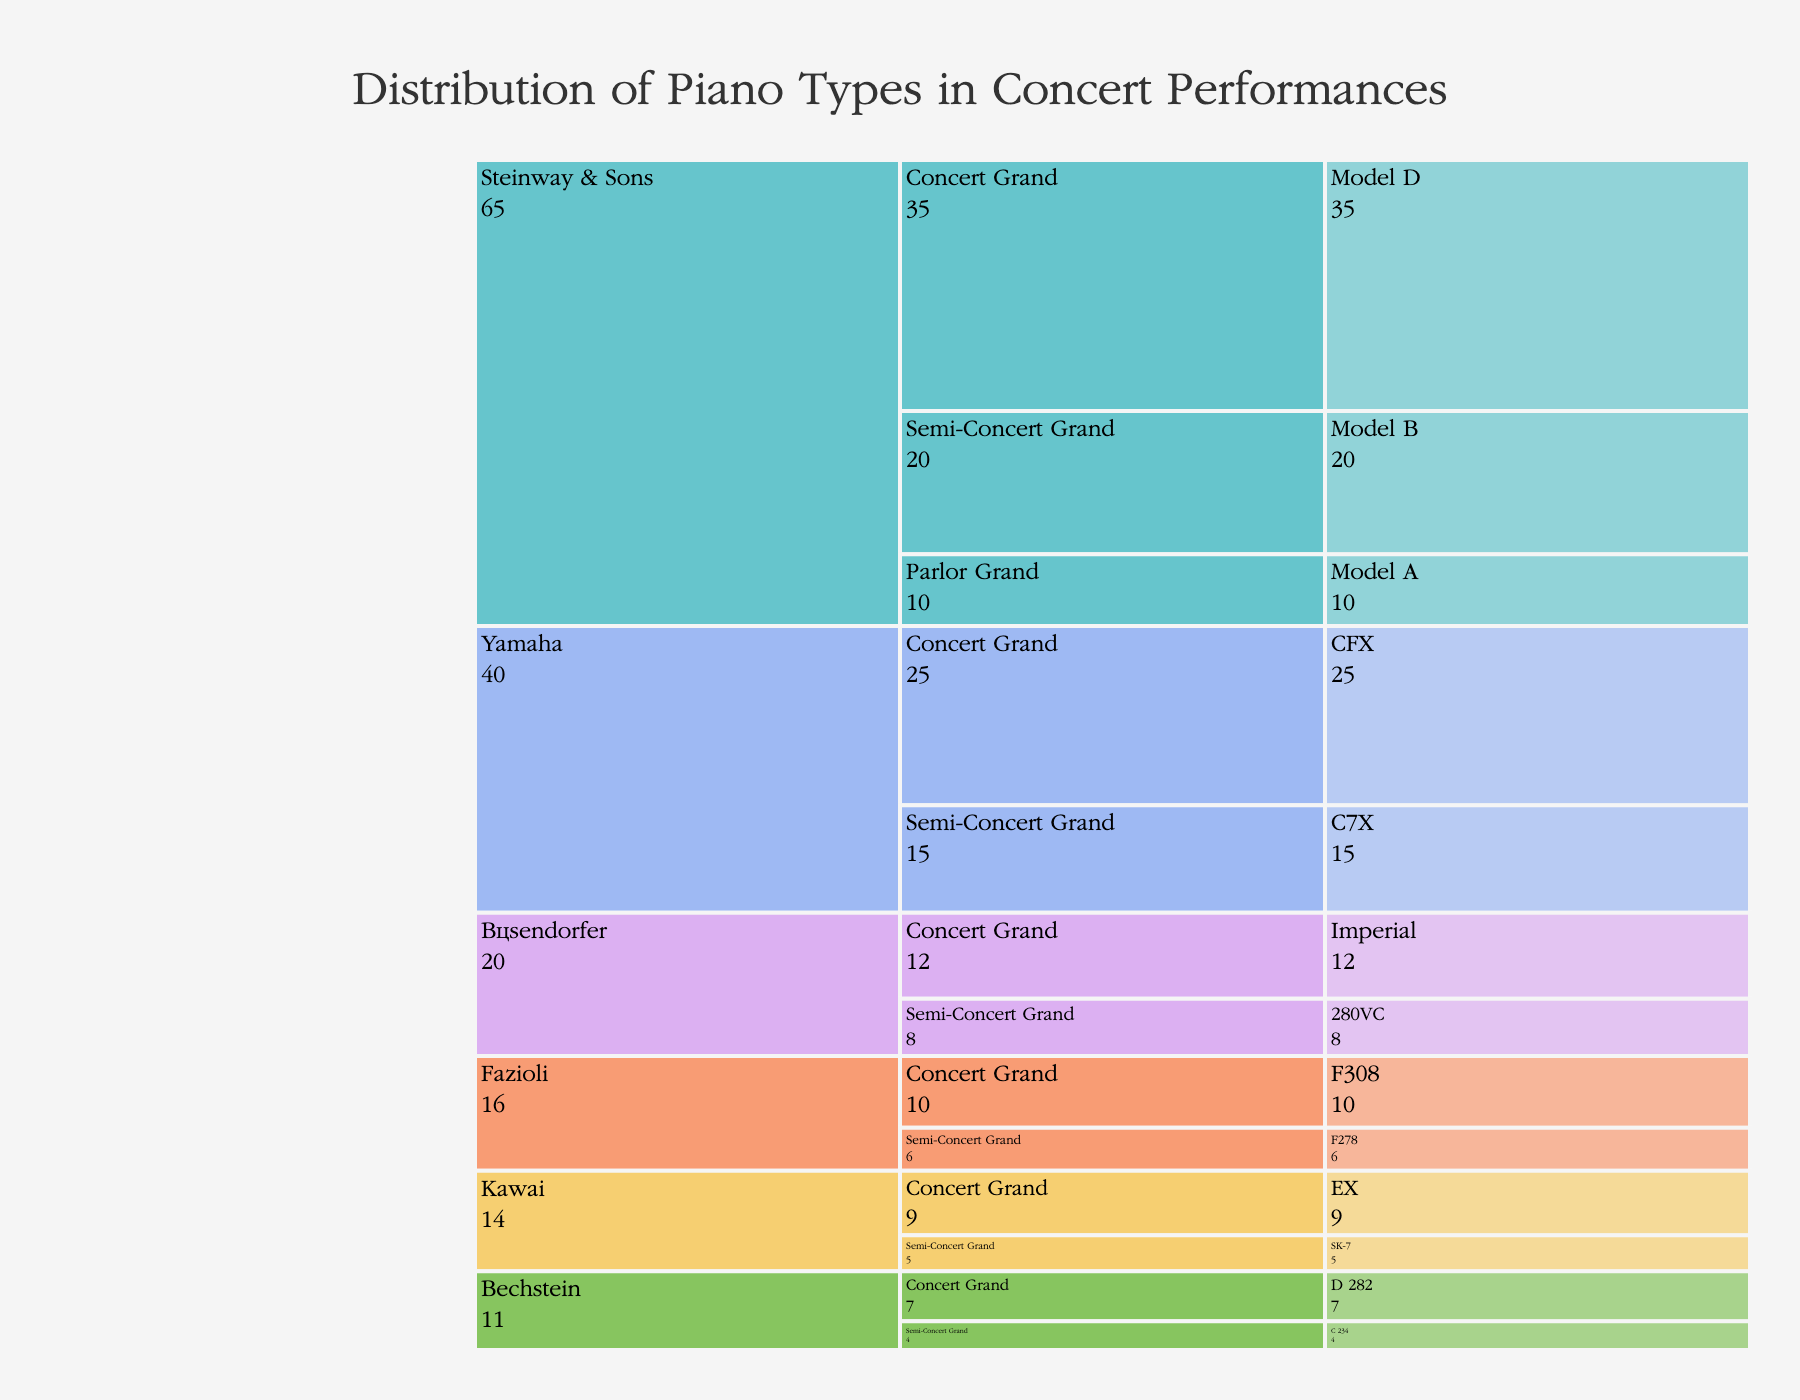Which piano model is the most used in concert performances? Look for the model with the highest usage value. The Steinway & Sons Model D has the highest usage with 35 performances.
Answer: Steinway & Sons Model D How many concert grand models from all manufacturers are used in total? Add the usage values of all concert grand models. Steinway & Sons Model D (35), Yamaha CFX (25), Bösendorfer Imperial (12), Fazioli F308 (10), Kawai EX (9), and Bechstein D 282 (7) sum up to 98.
Answer: 98 Which manufacturer has the highest total usage across all their piano models? Sum the usage values for each manufacturer. Steinway & Sons (35+20+10=65), Yamaha (25+15=40), Bösendorfer (12+8=20), Fazioli (10+6=16), Kawai (9+5=14), Bechstein (7+4=11). Steinway & Sons has the highest with 65.
Answer: Steinway & Sons What is the difference in usage between the most used and the least used models of Steinway & Sons? Subtract the usage of the least used model from the most used model for Steinway & Sons. Model D (35) - Model A (10) = 25.
Answer: 25 How many manufacturers have at least one model with a usage of 15 or more? Identify manufacturers with models having usage of 15 or more. Steinway & Sons (35, 20), Yamaha (25, 15). There are 2 such manufacturers.
Answer: 2 What is the average usage of the concert grand models from Yamaha and Bösendorfer? Add the usage values of concert grand models from Yamaha (25) and Bösendorfer (12), then divide by 2. (25 + 12) / 2 = 18.5
Answer: 18.5 Which semi-concert grand model has the lowest usage across all manufacturers? Look for the smallest value among the semi-concert grand models. Bechstein C 234 has the lowest usage with 4 performances.
Answer: Bechstein C 234 Compare the total usage of concert grand models with semi-concert grand models for Fazioli. Which is greater? Sum the respective usage values for Fazioli's concert grand (10) and semi-concert grand (6). Compare 10 and 6; 10 is greater.
Answer: Concert grand Which category has more models in the chart, concert grand or semi-concert grand? Count the models in each category. Concert grand has 6 models and semi-concert grand has 6 models. Both have the same number of models.
Answer: Same number If the number of uses for the Bösendorfer semi-concert grand model increased by 4, how would that affect the ranking of its total usage among manufacturers? Bösendorfer's semi-concert grand model (8) would become 12. The new total usage for all Bösendorfer models would be (12 + 12) = 24. Compare this with other manufacturers' total: Steinway & Sons (65), Yamaha (40), Fazioli (16), Kawai (14), Bechstein (11). Bösendorfer would remain in third place.
Answer: No change in ranking 